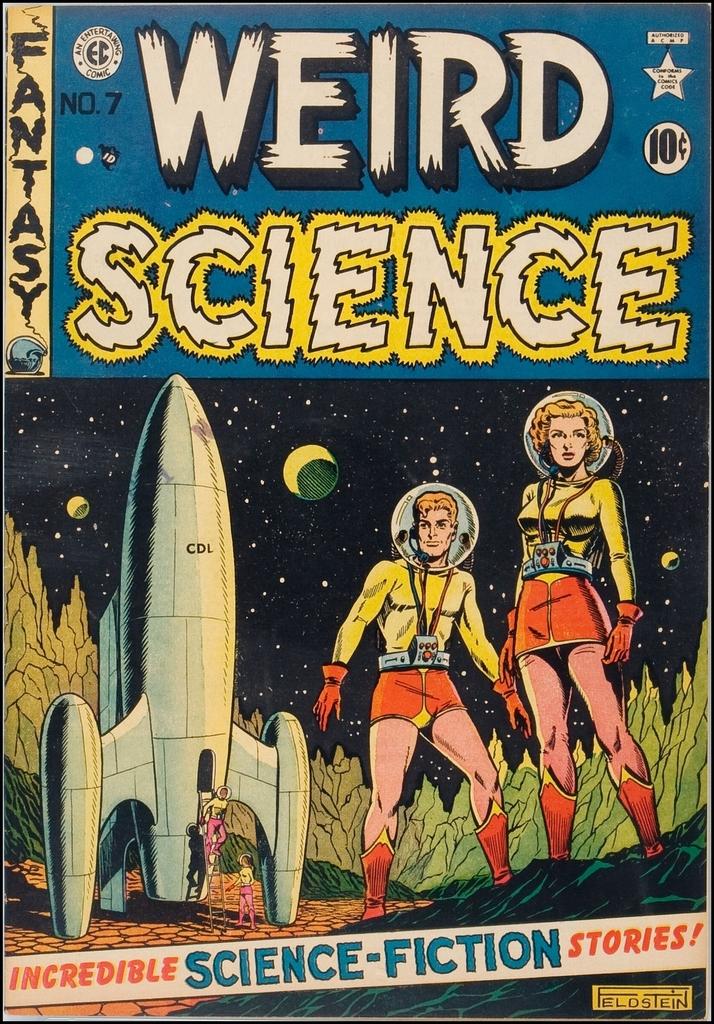What kind of science is it?
Provide a succinct answer. Weird. 